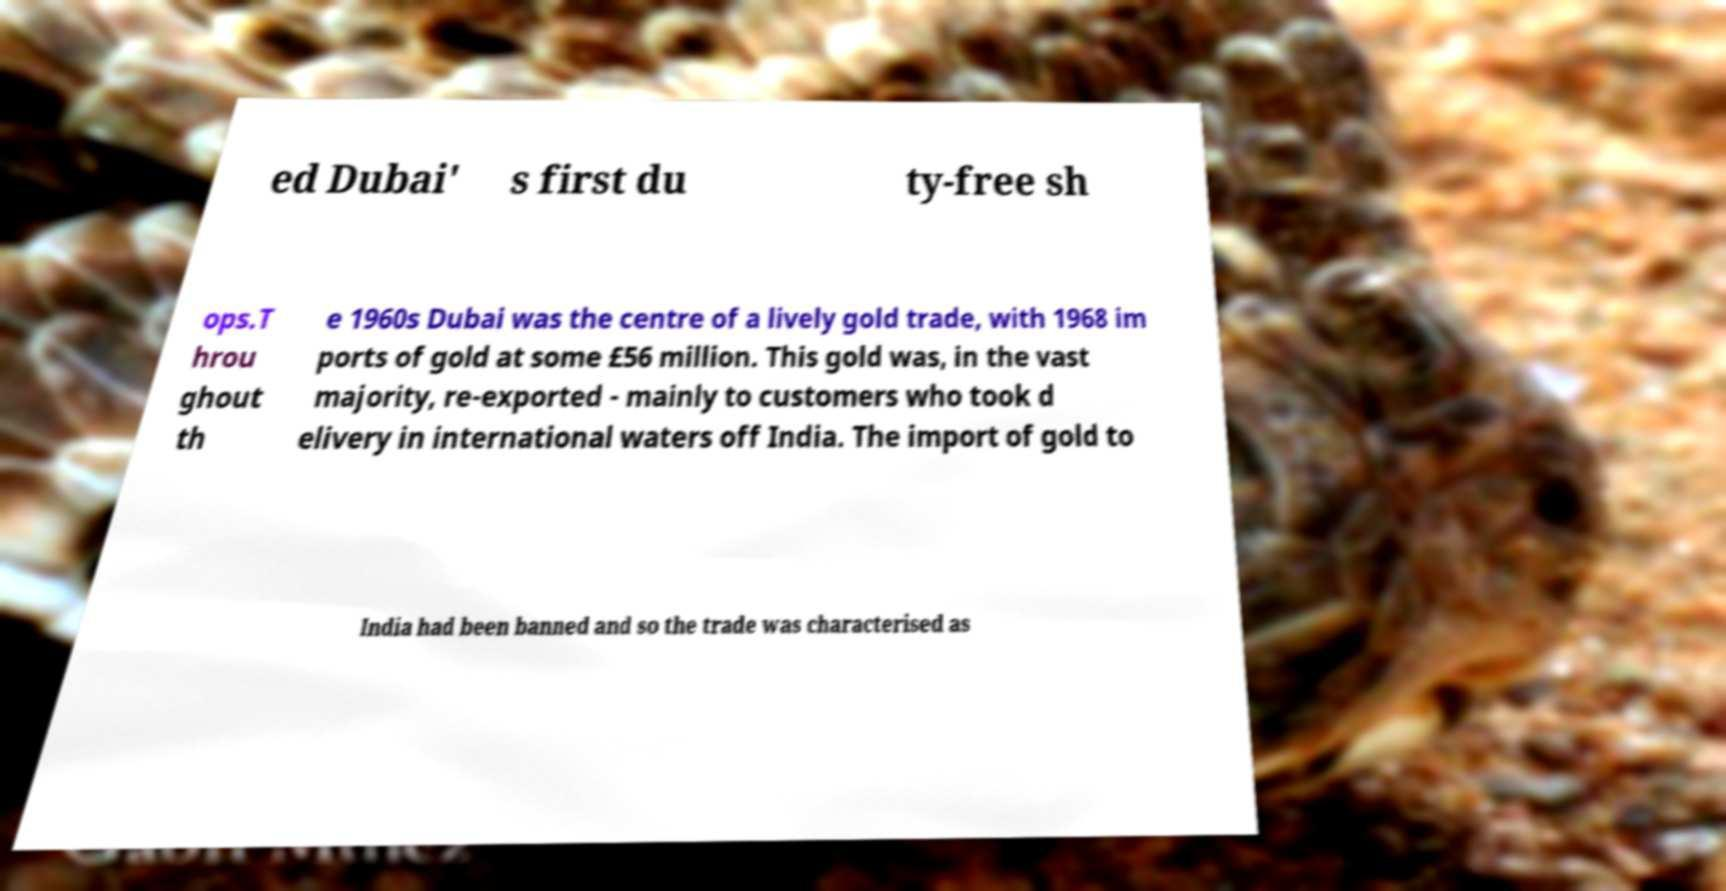Can you read and provide the text displayed in the image?This photo seems to have some interesting text. Can you extract and type it out for me? ed Dubai' s first du ty-free sh ops.T hrou ghout th e 1960s Dubai was the centre of a lively gold trade, with 1968 im ports of gold at some £56 million. This gold was, in the vast majority, re-exported - mainly to customers who took d elivery in international waters off India. The import of gold to India had been banned and so the trade was characterised as 